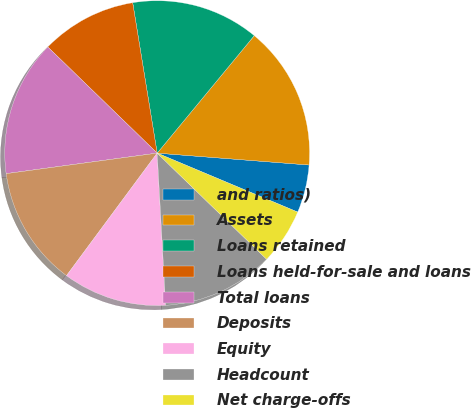<chart> <loc_0><loc_0><loc_500><loc_500><pie_chart><fcel>and ratios)<fcel>Assets<fcel>Loans retained<fcel>Loans held-for-sale and loans<fcel>Total loans<fcel>Deposits<fcel>Equity<fcel>Headcount<fcel>Net charge-offs<nl><fcel>5.08%<fcel>15.25%<fcel>13.56%<fcel>10.17%<fcel>14.41%<fcel>12.71%<fcel>11.02%<fcel>11.86%<fcel>5.93%<nl></chart> 